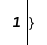Convert code to text. <code><loc_0><loc_0><loc_500><loc_500><_Awk_>}
</code> 